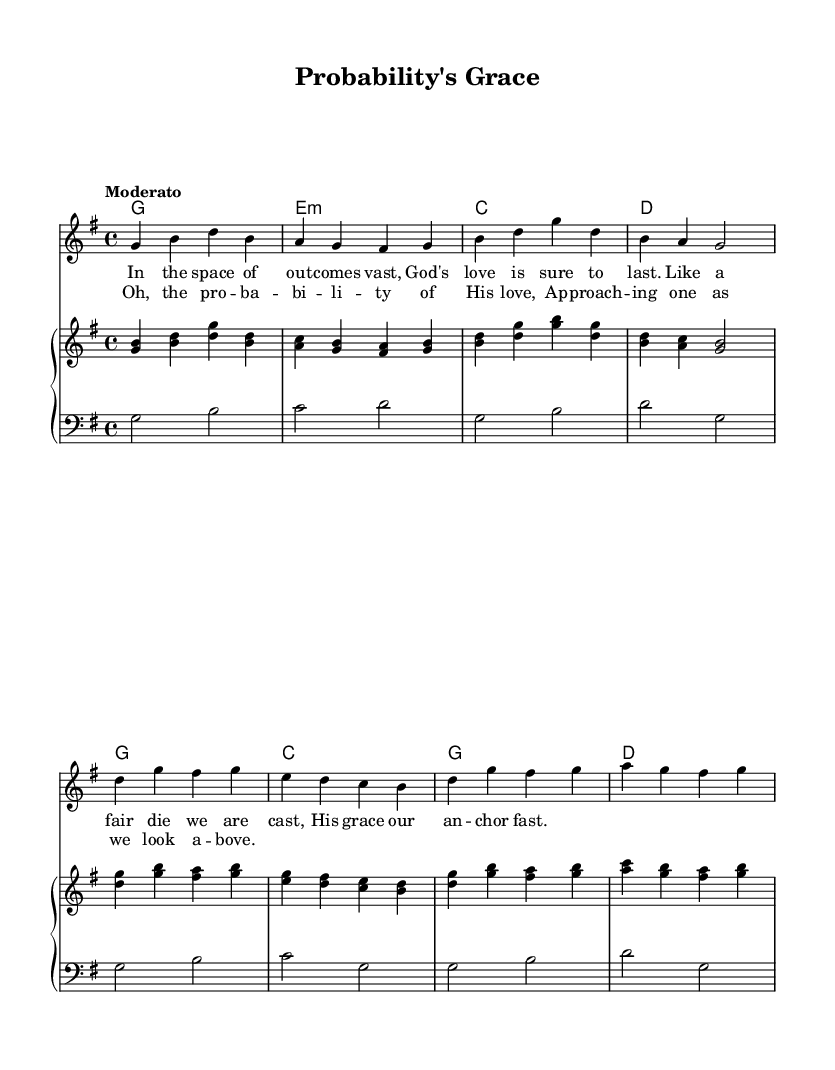What is the key signature of this music? The key signature is G major, which has one sharp (F#). The first thing to look for is the key signature indicators at the beginning of the staff. In this case, it shows one sharp, meaning the music is in G major.
Answer: G major What is the time signature of this music? The time signature is 4/4, which indicates that there are four beats in a measure, and the quarter note gets one beat. This is shown at the start of the music, following the key signature.
Answer: 4/4 What is the tempo marking of this piece? The tempo marking is "Moderato", indicating a moderate pace for the piece. The tempo marking is typically found at the beginning of the score, right after the time signature, specifying the speed at which the music should be played.
Answer: Moderato How many measures are in the verse? The verse consists of 4 measures. To determine this, one can count the measure bars in the first section labeled “Verse” in the score, where there are exactly four vertical lines separating the measures.
Answer: 4 What is the final chord of the chorus? The final chord of the chorus is D major. This can be identified by looking at the last measure of the chorus section and observing the chord symbols notated above the staff. The notation shows a D chord.
Answer: D What numerical value represents the total number of notes in the melody? The total number of notes in the melody is 22. By counting each distinct note in the melody line starting from the first note to the last, one arrives at the total count, which incorporates all notes used in the melody section.
Answer: 22 What is the first lyric line of the verse? The first lyric line of the verse is "In the space of out -- comes vast,". This can be confirmed by looking at the lyrics aligned with the respective melody notes at the beginning of the verse section.
Answer: In the space of out -- comes vast 